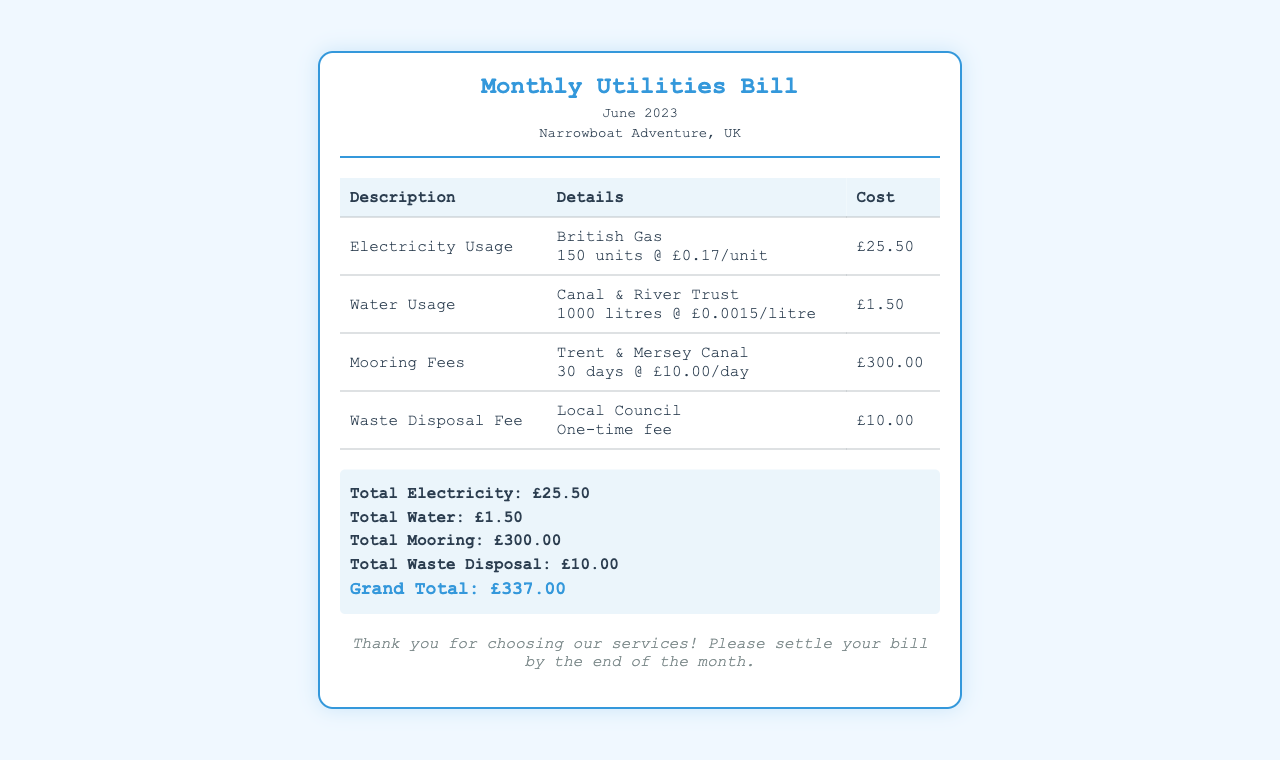What is the total cost of electricity usage? The total cost of electricity usage is clearly stated in the document under the description "Electricity Usage."
Answer: £25.50 How many days does the mooring fee cover? The mooring fee covers the period mentioned under "Mooring Fees," specifying the number of days.
Answer: 30 days What is the rate per litre for water usage? The document states the rate per litre for water usage under the "Water Usage" section.
Answer: £0.0015/litre What is the grand total for the June utilities bill? The grand total is calculated and presented at the bottom of the summary section of the document.
Answer: £337.00 Who is the provider for electricity? The provider for electricity is mentioned in the details of the "Electricity Usage" section.
Answer: British Gas What is the fee for waste disposal? The waste disposal fee is indicated in the document as a one-time fee under the "Waste Disposal Fee" section.
Answer: £10.00 How much is charged per day for mooring? The daily charge for mooring is specified in the "Mooring Fees" section of the document.
Answer: £10.00/day What is the total charges for water usage? The total charges for water usage are summarized in the document under the "Water Usage" section.
Answer: £1.50 